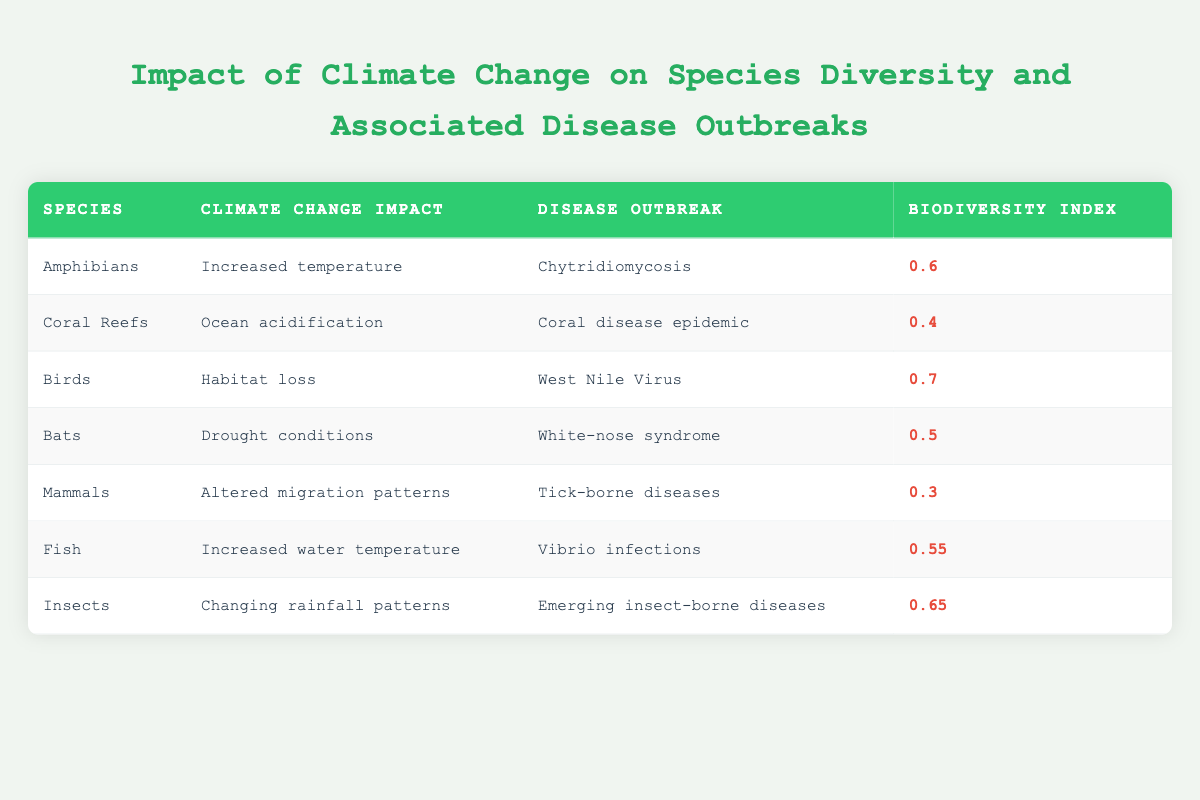What is the biodiversity index of Birds? The biodiversity index for Birds is found directly in the table under the "Biodiversity Index" column corresponding to the row for Birds.
Answer: 0.7 Is the disease outbreak caused by Bats listed in the table? Yes, the table includes Bats and lists White-nose syndrome as the disease outbreak related to this species.
Answer: Yes Which species has the lowest biodiversity index? By scanning the "Biodiversity Index" column, the lowest value is 0.3, corresponding to Mammals.
Answer: Mammals What is the average biodiversity index of the species listed in the table? To calculate the average, sum all the biodiversity index values: 0.6 + 0.4 + 0.7 + 0.5 + 0.3 + 0.55 + 0.65 = 3.4. There are 7 species, so the average is 3.4 / 7 ≈ 0.486.
Answer: Approximately 0.486 Does increased temperature impact species other than Amphibians? No, the table shows increased temperature impacts only Amphibians; no other species are affected by this climate change impact.
Answer: No What is the total number of disease outbreaks listed in the table? The total number of disease outbreaks can be counted by listing each unique outbreak in the "Disease Outbreak" column. There are six unique disease outbreaks mentioned.
Answer: 6 Which species experience habitat loss as a climate change impact, and what is their biodiversity index? The species experiencing habitat loss is Birds, and their biodiversity index is 0.7. The corresponding row directly indicates this information.
Answer: Birds, 0.7 What relationship can be observed between the biodiversity index and the types of disease outbreaks for the species? Analyzing the table, a general observation is that lower biodiversity indices tend to correlate with more severe or complex disease outbreaks, as seen with Mammals and Tick-borne diseases.
Answer: Lower biodiversity may relate to more severe outbreaks 